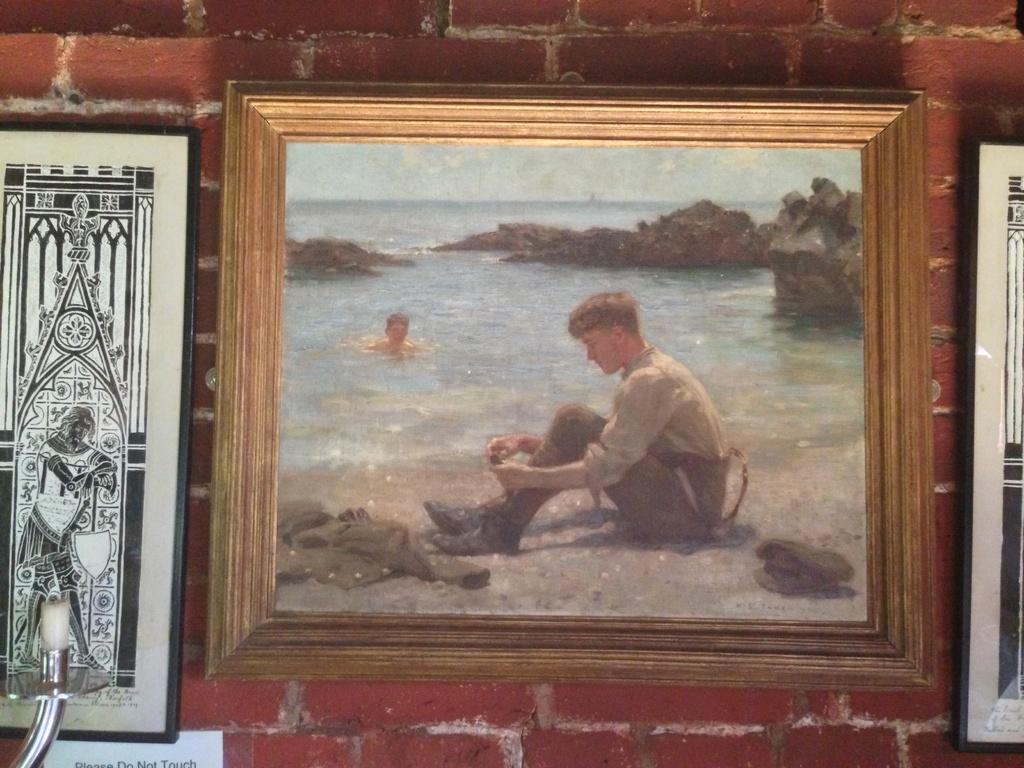How many frames are attached to the wall in the image? There are three frames attached to the wall in the image. What is depicted in the first frame? The first frame contains a person sitting on the seashore. What is depicted in the second frame? The second frame contains a person in the water. What type of natural feature is visible in the image? Rocks are visible in the image. What is visible in the background of the image? The sky is visible in the image. What type of squirrel can be seen climbing the rocks in the image? There is no squirrel present in the image; only rocks and the sky are visible in the background. 